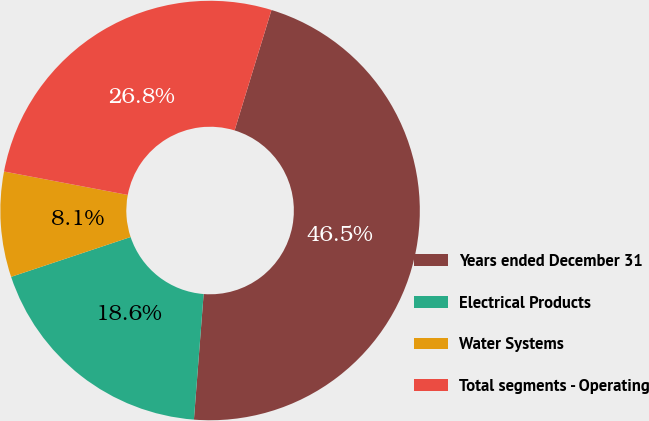Convert chart to OTSL. <chart><loc_0><loc_0><loc_500><loc_500><pie_chart><fcel>Years ended December 31<fcel>Electrical Products<fcel>Water Systems<fcel>Total segments - Operating<nl><fcel>46.5%<fcel>18.65%<fcel>8.1%<fcel>26.75%<nl></chart> 